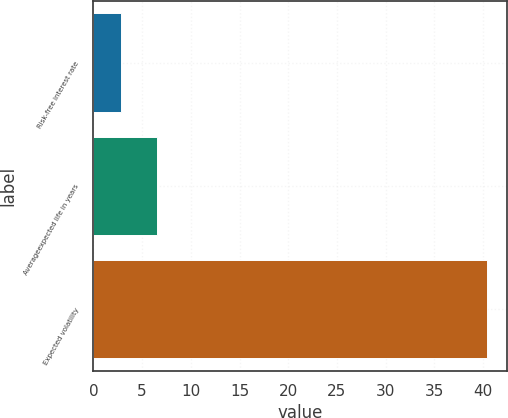Convert chart. <chart><loc_0><loc_0><loc_500><loc_500><bar_chart><fcel>Risk-free interest rate<fcel>Averageexpected life in years<fcel>Expected volatility<nl><fcel>2.8<fcel>6.56<fcel>40.4<nl></chart> 